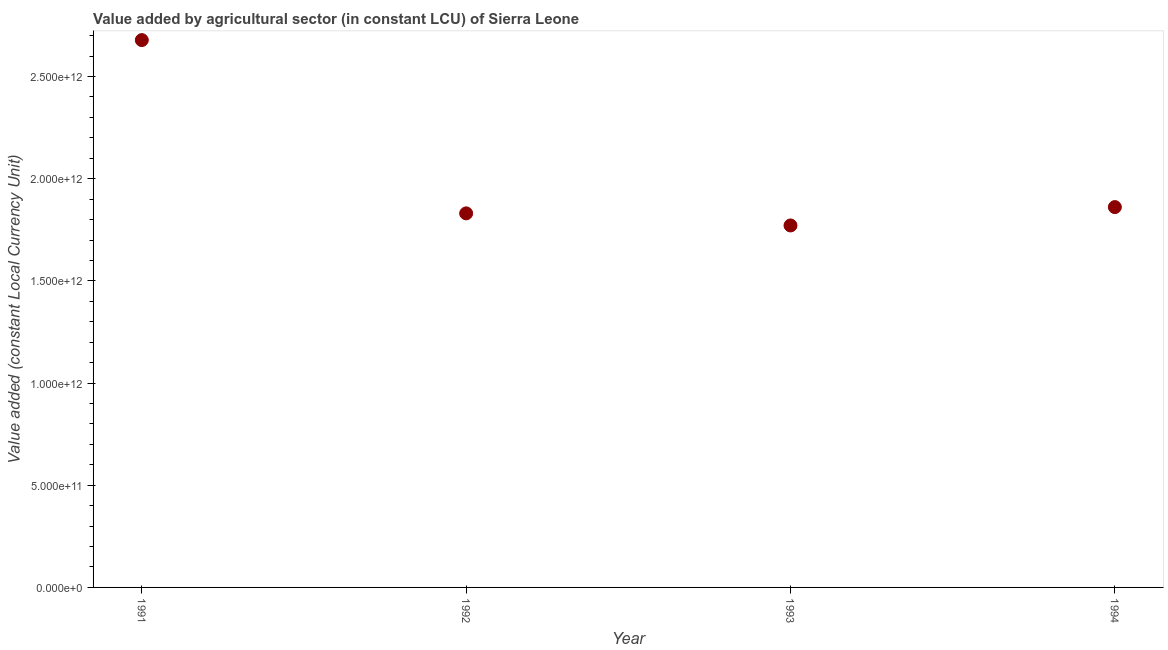What is the value added by agriculture sector in 1991?
Offer a terse response. 2.68e+12. Across all years, what is the maximum value added by agriculture sector?
Offer a terse response. 2.68e+12. Across all years, what is the minimum value added by agriculture sector?
Your answer should be very brief. 1.77e+12. What is the sum of the value added by agriculture sector?
Make the answer very short. 8.14e+12. What is the difference between the value added by agriculture sector in 1991 and 1993?
Make the answer very short. 9.07e+11. What is the average value added by agriculture sector per year?
Offer a very short reply. 2.04e+12. What is the median value added by agriculture sector?
Provide a succinct answer. 1.85e+12. What is the ratio of the value added by agriculture sector in 1993 to that in 1994?
Keep it short and to the point. 0.95. Is the value added by agriculture sector in 1991 less than that in 1992?
Ensure brevity in your answer.  No. Is the difference between the value added by agriculture sector in 1991 and 1993 greater than the difference between any two years?
Ensure brevity in your answer.  Yes. What is the difference between the highest and the second highest value added by agriculture sector?
Keep it short and to the point. 8.17e+11. What is the difference between the highest and the lowest value added by agriculture sector?
Provide a succinct answer. 9.07e+11. In how many years, is the value added by agriculture sector greater than the average value added by agriculture sector taken over all years?
Provide a succinct answer. 1. Does the value added by agriculture sector monotonically increase over the years?
Keep it short and to the point. No. What is the difference between two consecutive major ticks on the Y-axis?
Keep it short and to the point. 5.00e+11. What is the title of the graph?
Ensure brevity in your answer.  Value added by agricultural sector (in constant LCU) of Sierra Leone. What is the label or title of the X-axis?
Your response must be concise. Year. What is the label or title of the Y-axis?
Your response must be concise. Value added (constant Local Currency Unit). What is the Value added (constant Local Currency Unit) in 1991?
Your answer should be very brief. 2.68e+12. What is the Value added (constant Local Currency Unit) in 1992?
Give a very brief answer. 1.83e+12. What is the Value added (constant Local Currency Unit) in 1993?
Offer a terse response. 1.77e+12. What is the Value added (constant Local Currency Unit) in 1994?
Ensure brevity in your answer.  1.86e+12. What is the difference between the Value added (constant Local Currency Unit) in 1991 and 1992?
Your response must be concise. 8.48e+11. What is the difference between the Value added (constant Local Currency Unit) in 1991 and 1993?
Give a very brief answer. 9.07e+11. What is the difference between the Value added (constant Local Currency Unit) in 1991 and 1994?
Give a very brief answer. 8.17e+11. What is the difference between the Value added (constant Local Currency Unit) in 1992 and 1993?
Provide a short and direct response. 5.92e+1. What is the difference between the Value added (constant Local Currency Unit) in 1992 and 1994?
Offer a terse response. -3.07e+1. What is the difference between the Value added (constant Local Currency Unit) in 1993 and 1994?
Make the answer very short. -8.98e+1. What is the ratio of the Value added (constant Local Currency Unit) in 1991 to that in 1992?
Your response must be concise. 1.46. What is the ratio of the Value added (constant Local Currency Unit) in 1991 to that in 1993?
Ensure brevity in your answer.  1.51. What is the ratio of the Value added (constant Local Currency Unit) in 1991 to that in 1994?
Provide a short and direct response. 1.44. What is the ratio of the Value added (constant Local Currency Unit) in 1992 to that in 1993?
Your response must be concise. 1.03. What is the ratio of the Value added (constant Local Currency Unit) in 1993 to that in 1994?
Provide a short and direct response. 0.95. 